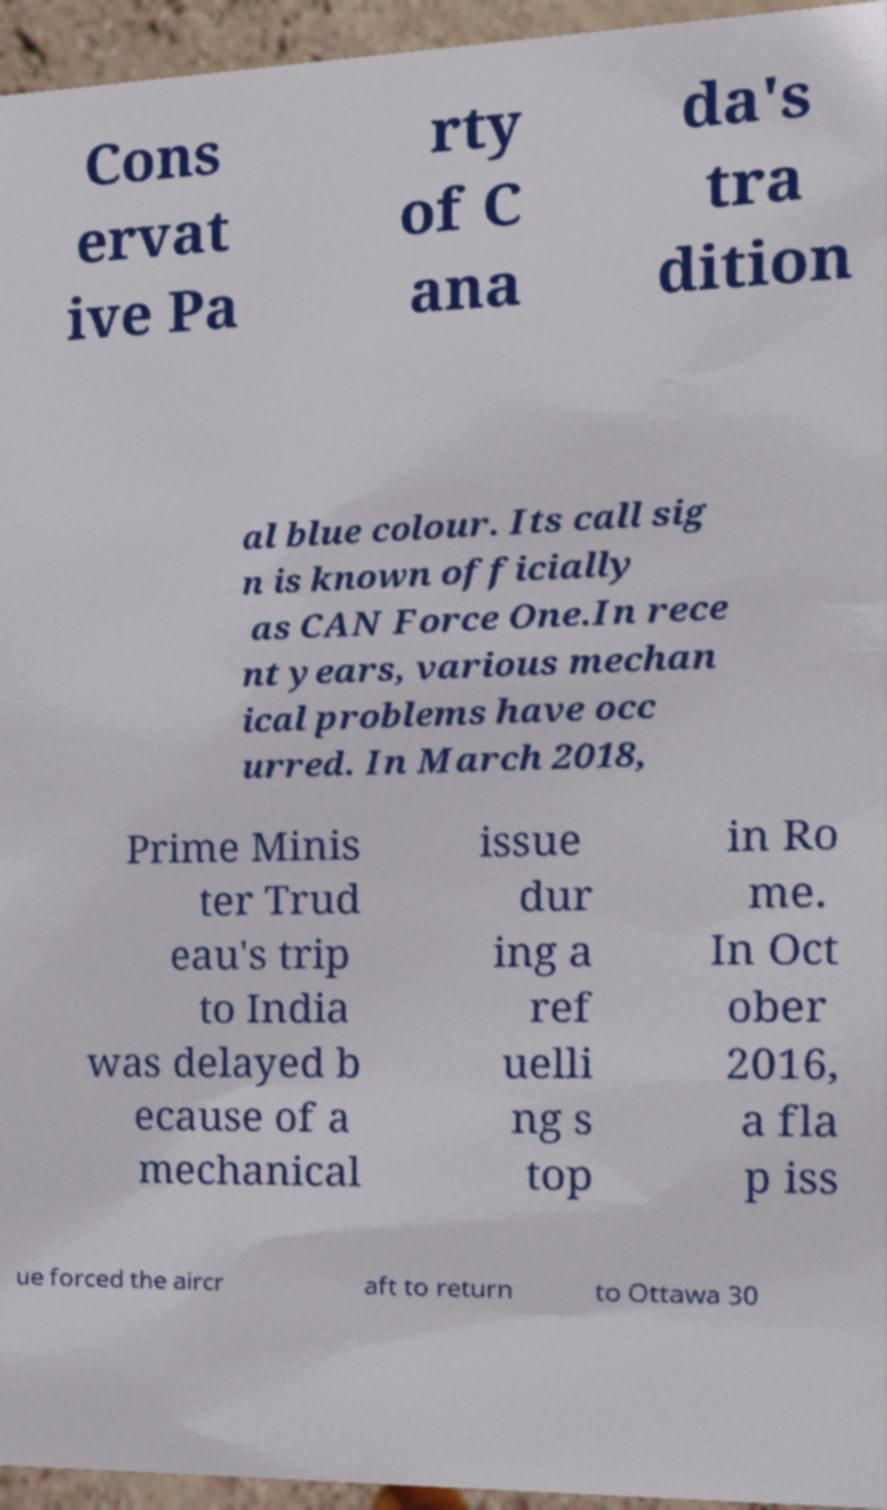I need the written content from this picture converted into text. Can you do that? Cons ervat ive Pa rty of C ana da's tra dition al blue colour. Its call sig n is known officially as CAN Force One.In rece nt years, various mechan ical problems have occ urred. In March 2018, Prime Minis ter Trud eau's trip to India was delayed b ecause of a mechanical issue dur ing a ref uelli ng s top in Ro me. In Oct ober 2016, a fla p iss ue forced the aircr aft to return to Ottawa 30 